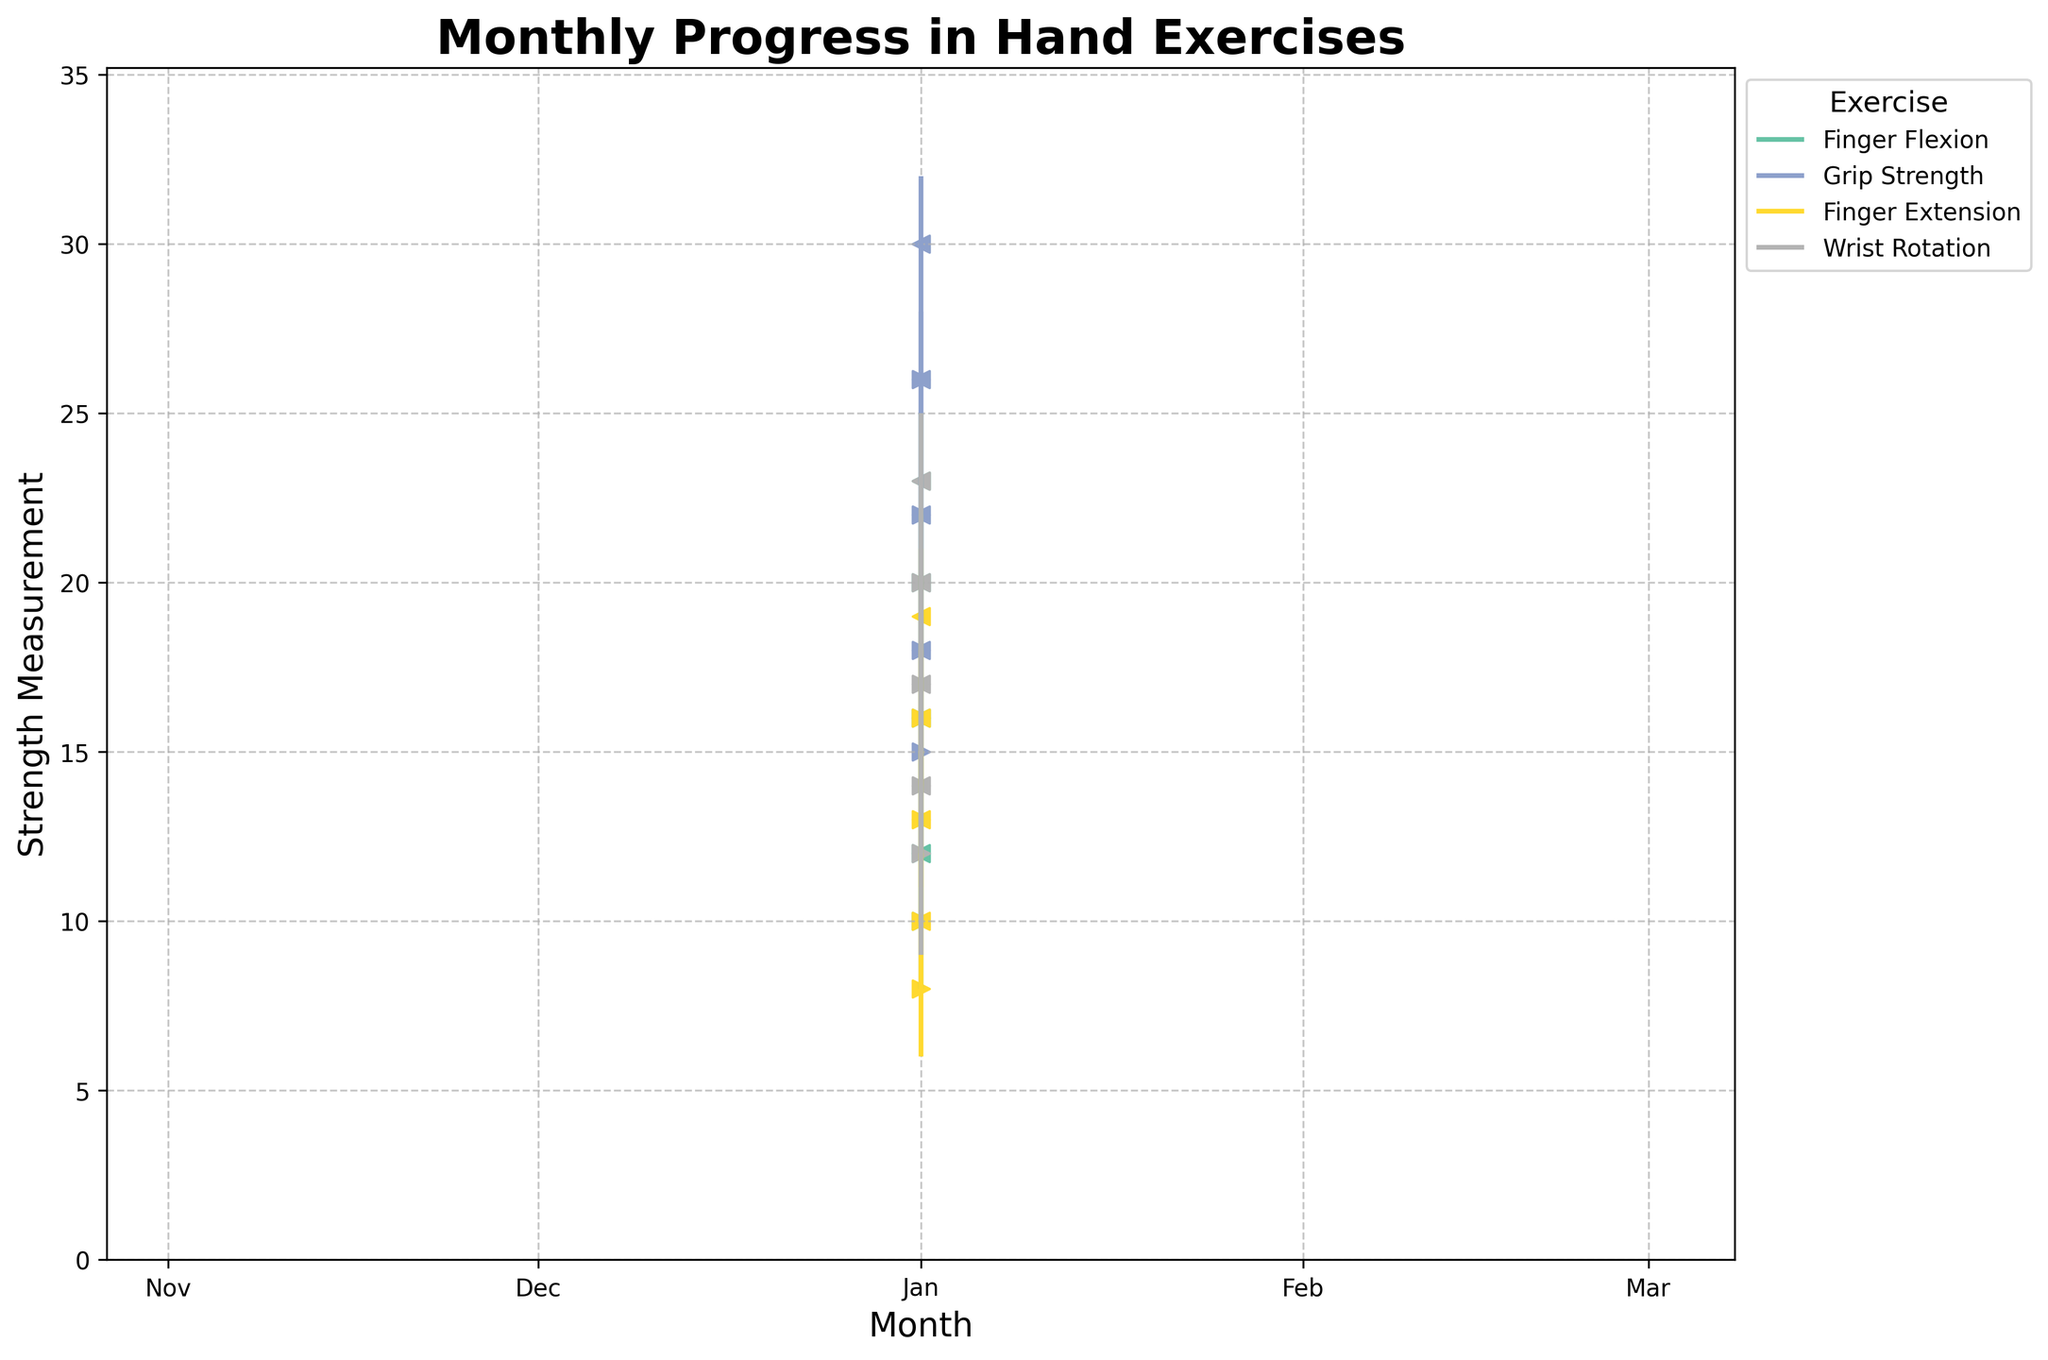What is the title of the chart? The title is displayed at the top of the chart, indicating the overall subject of the visualization. It helps viewers quickly understand the context of the data being presented.
Answer: Monthly Progress in Hand Exercises Which exercise shows the highest value in April? This requires identifying the highest value (High) for each exercise in April and comparing them. Finger Flexion: 25, Grip Strength: 32, Finger Extension: 21, Wrist Rotation: 25. The highest is 32 for Grip Strength.
Answer: Grip Strength What is the range of strength measurement for Finger Extension in March? The range is calculated as the difference between the high and the low values. For Finger Extension in March, the high is 18 and the low is 11. Therefore, the range is 18 - 11 = 7.
Answer: 7 How does the Close value of Finger Flexion change from January to April? Track the Close values for Finger Flexion across the months: January (12), February (16), March (20), and April (23). The values are increasing progressively each month.
Answer: Increasing Which month shows the highest overall improvement in Grip Strength? Improvement is measured as the difference between the Close value of a month and the Open value of the preceding month. From Jan to Apr: Feb (22-15=7), Mar (26-18=8), Apr (30-22=8). Both March and April have the highest improvement of 8.
Answer: March and April How do the high values of Wrist Rotation progress over the months? Observe the high values for Wrist Rotation across the months: January (16), February (19), March (22), and April (25). The values increase progressively each month.
Answer: Increasing Which exercise has the smallest range in January? Calculate the range (High - Low) for each exercise in January. Finger Flexion: 15-8=7, Grip Strength: 20-12=8, Finger Extension: 12-6=6, Wrist Rotation: 16-9=7. The smallest range is 6 for Finger Extension.
Answer: Finger Extension What are the Close values for Grip Strength in February and March? Find the Close values for Grip Strength in the specified months: February (22) and March (26).
Answer: 22 and 26 